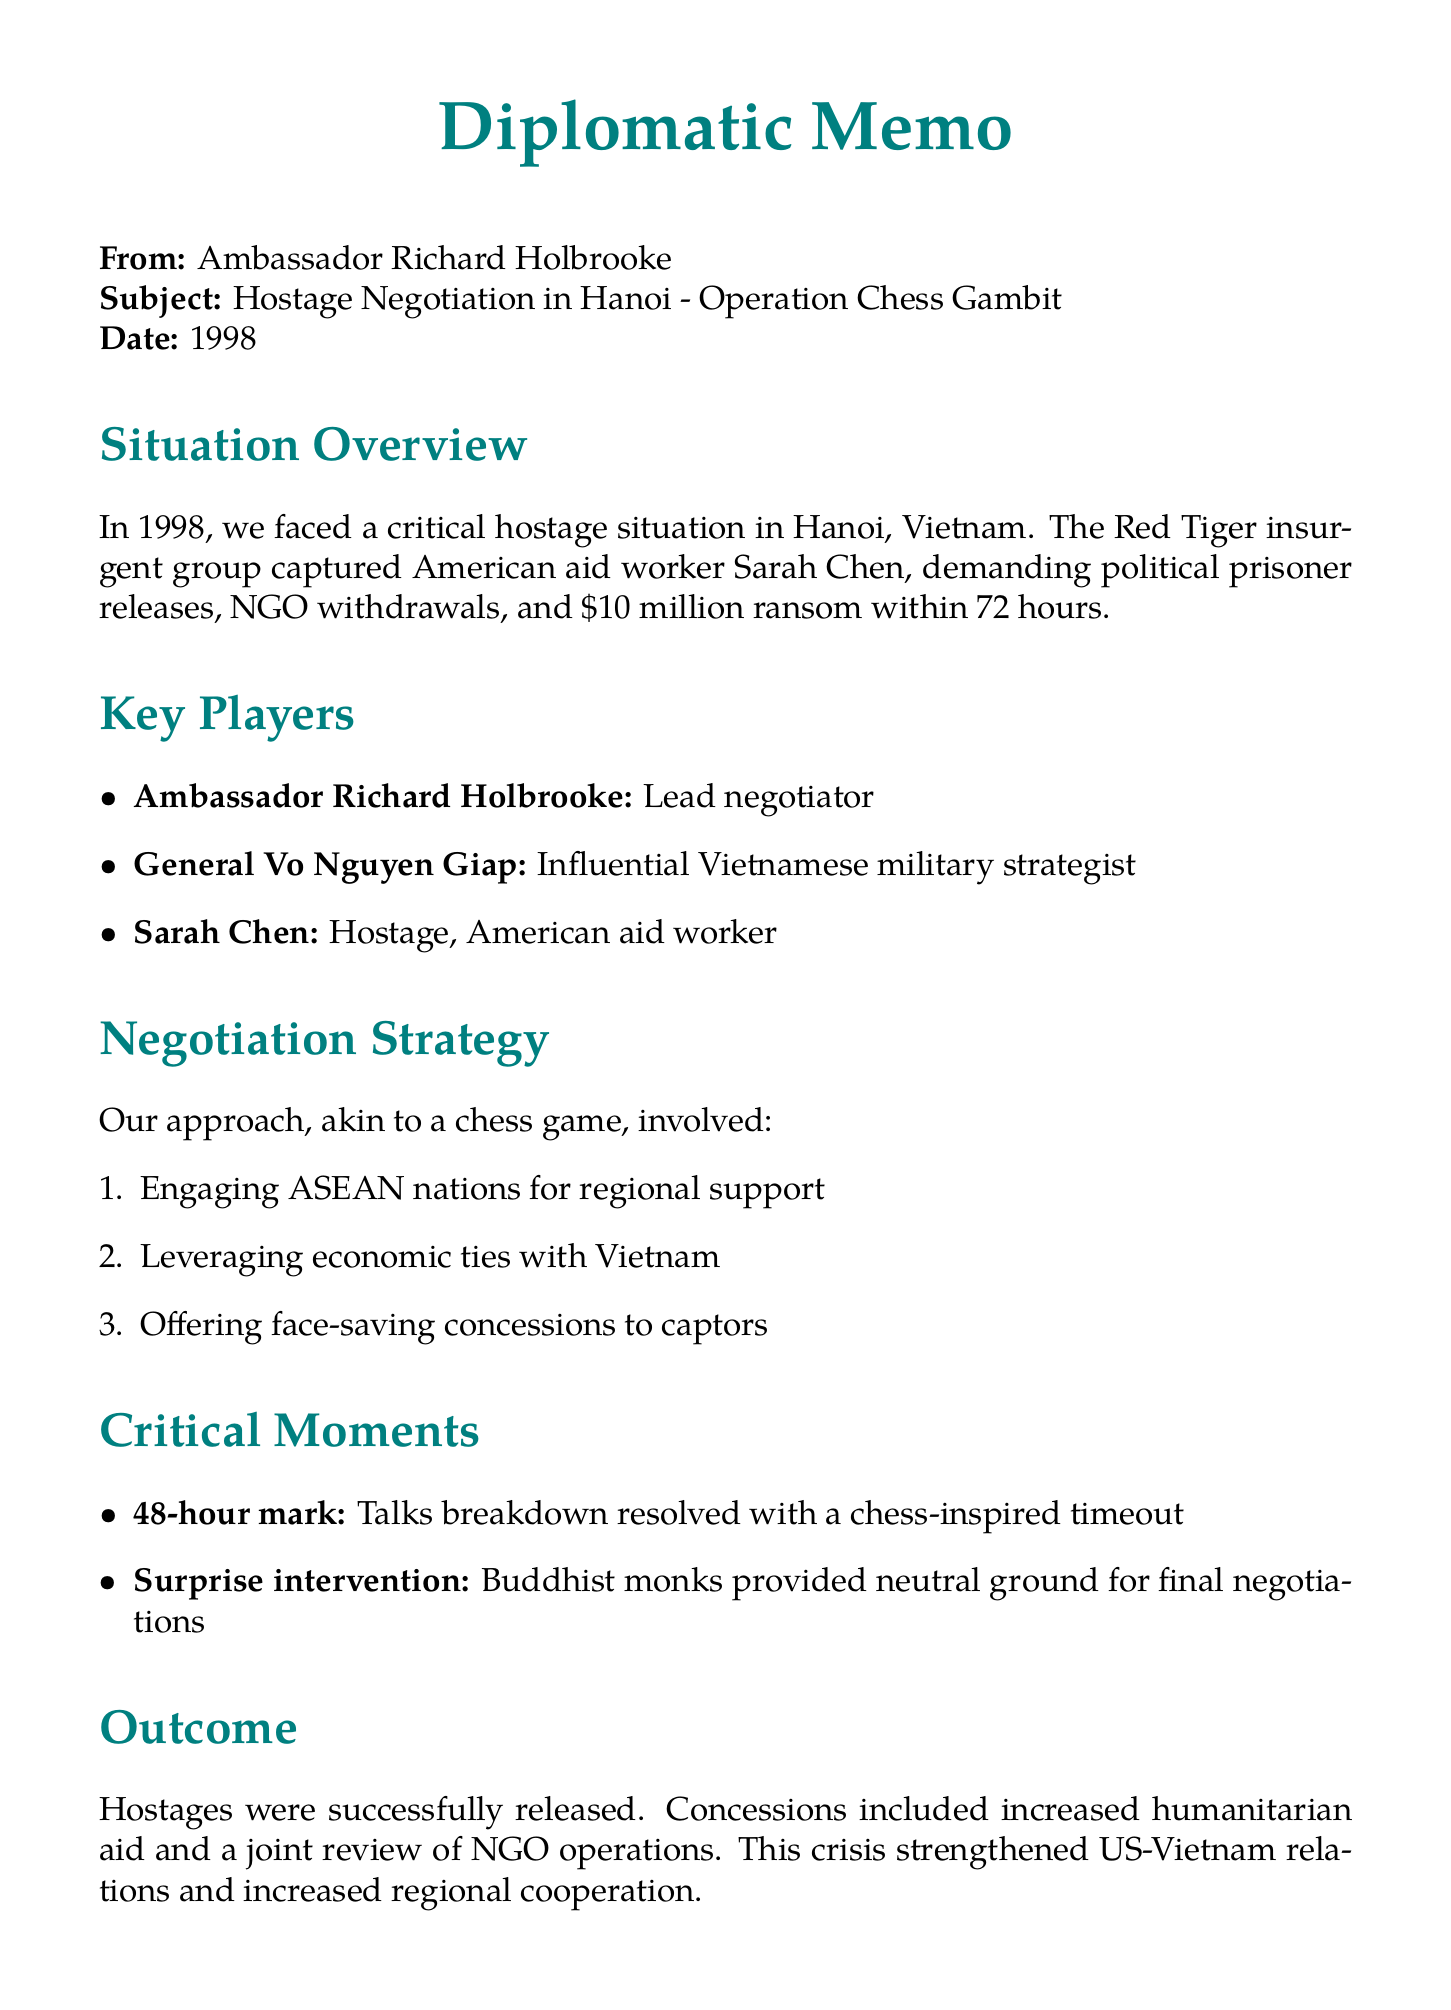What is the chapter title? The title of the chapter is a specific heading mentioned at the beginning of the document.
Answer: High Stakes in Hanoi: A Diplomatic Chess Game What year did the hostage negotiation take place? The year is referenced in the document, indicating when the events occurred.
Answer: 1998 Who was the lead negotiator? This question refers to the person designated in the document as the primary figure in negotiations.
Answer: Ambassador Richard Holbrooke What was one of the demands of the captors? This question focuses on one of the specific requests made by the insurgents during the negotiation process.
Answer: Release of political prisoners What notable intervention occurred during the negotiations? This question requires understanding which event significantly affected the negotiation outcome.
Answer: Surprise intervention by Buddhist monks How did the outcome affect US-Vietnam relations? This question seeks to understand the impact of the negotiation results on international relations as detailed in the memo.
Answer: Strengthened US-Vietnam relations What is the main analogy used to describe the negotiation strategy? This question highlights a specific metaphor mentioned to explain the negotiation approach.
Answer: Sacrificing a pawn to protect the queen What was a critical moment in the talks? This question refers to a significant event during the negotiation, described in the document.
Answer: Breakdown in talks at 48-hour mark What is one lesson learned from the negotiation? This question aims to extract a key takeaway mentioned in the document regarding negotiation practices.
Answer: Patience is crucial in high-stakes negotiations 